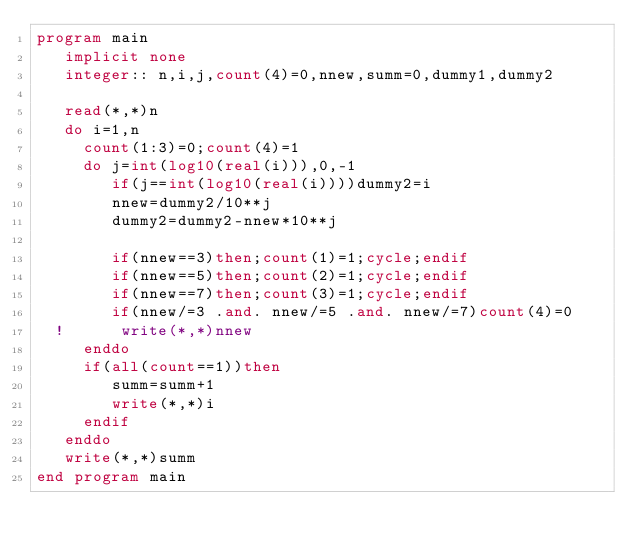<code> <loc_0><loc_0><loc_500><loc_500><_FORTRAN_>program main
   implicit none
   integer:: n,i,j,count(4)=0,nnew,summ=0,dummy1,dummy2
   
   read(*,*)n
   do i=1,n
     count(1:3)=0;count(4)=1
     do j=int(log10(real(i))),0,-1
        if(j==int(log10(real(i))))dummy2=i
        nnew=dummy2/10**j
        dummy2=dummy2-nnew*10**j
        
        if(nnew==3)then;count(1)=1;cycle;endif
        if(nnew==5)then;count(2)=1;cycle;endif
        if(nnew==7)then;count(3)=1;cycle;endif
        if(nnew/=3 .and. nnew/=5 .and. nnew/=7)count(4)=0
  !      write(*,*)nnew
     enddo
     if(all(count==1))then
        summ=summ+1
        write(*,*)i
     endif
   enddo
   write(*,*)summ
end program main
</code> 